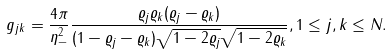Convert formula to latex. <formula><loc_0><loc_0><loc_500><loc_500>g _ { j k } = \frac { 4 \pi } { \eta _ { - } ^ { 2 } } \frac { \varrho _ { j } \varrho _ { k } ( \varrho _ { j } - \varrho _ { k } ) } { ( 1 - \varrho _ { j } - \varrho _ { k } ) \sqrt { 1 - 2 \varrho _ { j } } \sqrt { 1 - 2 \varrho _ { k } } } , 1 \leq j , k \leq N .</formula> 